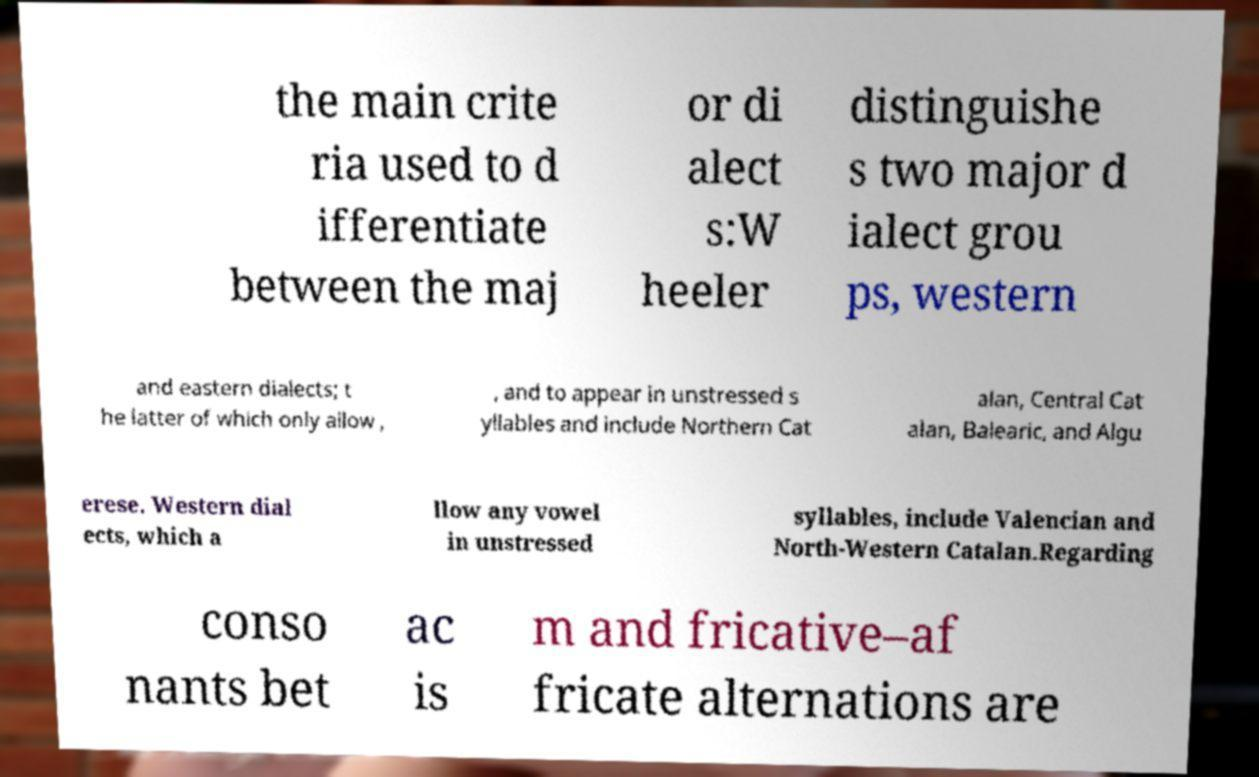For documentation purposes, I need the text within this image transcribed. Could you provide that? the main crite ria used to d ifferentiate between the maj or di alect s:W heeler distinguishe s two major d ialect grou ps, western and eastern dialects; t he latter of which only allow , , and to appear in unstressed s yllables and include Northern Cat alan, Central Cat alan, Balearic, and Algu erese. Western dial ects, which a llow any vowel in unstressed syllables, include Valencian and North-Western Catalan.Regarding conso nants bet ac is m and fricative–af fricate alternations are 